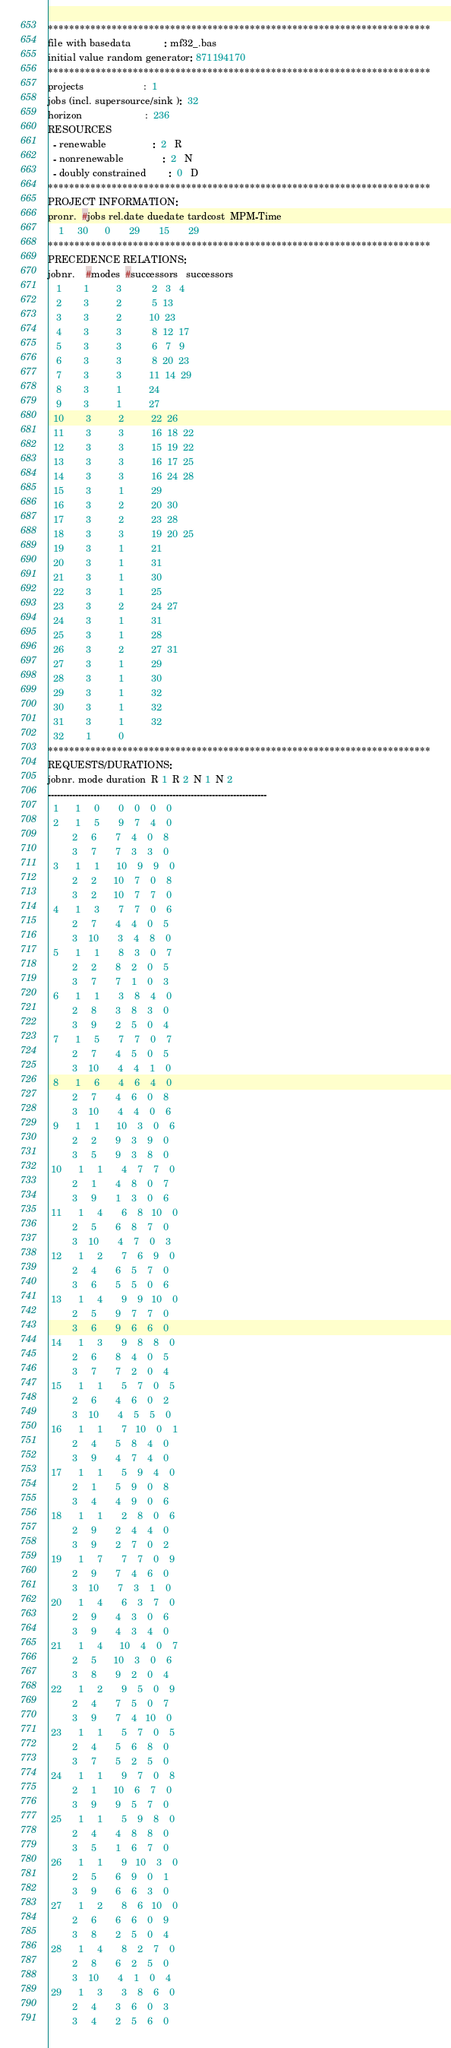Convert code to text. <code><loc_0><loc_0><loc_500><loc_500><_ObjectiveC_>************************************************************************
file with basedata            : mf32_.bas
initial value random generator: 871194170
************************************************************************
projects                      :  1
jobs (incl. supersource/sink ):  32
horizon                       :  236
RESOURCES
  - renewable                 :  2   R
  - nonrenewable              :  2   N
  - doubly constrained        :  0   D
************************************************************************
PROJECT INFORMATION:
pronr.  #jobs rel.date duedate tardcost  MPM-Time
    1     30      0       29       15       29
************************************************************************
PRECEDENCE RELATIONS:
jobnr.    #modes  #successors   successors
   1        1          3           2   3   4
   2        3          2           5  13
   3        3          2          10  23
   4        3          3           8  12  17
   5        3          3           6   7   9
   6        3          3           8  20  23
   7        3          3          11  14  29
   8        3          1          24
   9        3          1          27
  10        3          2          22  26
  11        3          3          16  18  22
  12        3          3          15  19  22
  13        3          3          16  17  25
  14        3          3          16  24  28
  15        3          1          29
  16        3          2          20  30
  17        3          2          23  28
  18        3          3          19  20  25
  19        3          1          21
  20        3          1          31
  21        3          1          30
  22        3          1          25
  23        3          2          24  27
  24        3          1          31
  25        3          1          28
  26        3          2          27  31
  27        3          1          29
  28        3          1          30
  29        3          1          32
  30        3          1          32
  31        3          1          32
  32        1          0        
************************************************************************
REQUESTS/DURATIONS:
jobnr. mode duration  R 1  R 2  N 1  N 2
------------------------------------------------------------------------
  1      1     0       0    0    0    0
  2      1     5       9    7    4    0
         2     6       7    4    0    8
         3     7       7    3    3    0
  3      1     1      10    9    9    0
         2     2      10    7    0    8
         3     2      10    7    7    0
  4      1     3       7    7    0    6
         2     7       4    4    0    5
         3    10       3    4    8    0
  5      1     1       8    3    0    7
         2     2       8    2    0    5
         3     7       7    1    0    3
  6      1     1       3    8    4    0
         2     8       3    8    3    0
         3     9       2    5    0    4
  7      1     5       7    7    0    7
         2     7       4    5    0    5
         3    10       4    4    1    0
  8      1     6       4    6    4    0
         2     7       4    6    0    8
         3    10       4    4    0    6
  9      1     1      10    3    0    6
         2     2       9    3    9    0
         3     5       9    3    8    0
 10      1     1       4    7    7    0
         2     1       4    8    0    7
         3     9       1    3    0    6
 11      1     4       6    8   10    0
         2     5       6    8    7    0
         3    10       4    7    0    3
 12      1     2       7    6    9    0
         2     4       6    5    7    0
         3     6       5    5    0    6
 13      1     4       9    9   10    0
         2     5       9    7    7    0
         3     6       9    6    6    0
 14      1     3       9    8    8    0
         2     6       8    4    0    5
         3     7       7    2    0    4
 15      1     1       5    7    0    5
         2     6       4    6    0    2
         3    10       4    5    5    0
 16      1     1       7   10    0    1
         2     4       5    8    4    0
         3     9       4    7    4    0
 17      1     1       5    9    4    0
         2     1       5    9    0    8
         3     4       4    9    0    6
 18      1     1       2    8    0    6
         2     9       2    4    4    0
         3     9       2    7    0    2
 19      1     7       7    7    0    9
         2     9       7    4    6    0
         3    10       7    3    1    0
 20      1     4       6    3    7    0
         2     9       4    3    0    6
         3     9       4    3    4    0
 21      1     4      10    4    0    7
         2     5      10    3    0    6
         3     8       9    2    0    4
 22      1     2       9    5    0    9
         2     4       7    5    0    7
         3     9       7    4   10    0
 23      1     1       5    7    0    5
         2     4       5    6    8    0
         3     7       5    2    5    0
 24      1     1       9    7    0    8
         2     1      10    6    7    0
         3     9       9    5    7    0
 25      1     1       5    9    8    0
         2     4       4    8    8    0
         3     5       1    6    7    0
 26      1     1       9   10    3    0
         2     5       6    9    0    1
         3     9       6    6    3    0
 27      1     2       8    6   10    0
         2     6       6    6    0    9
         3     8       2    5    0    4
 28      1     4       8    2    7    0
         2     8       6    2    5    0
         3    10       4    1    0    4
 29      1     3       3    8    6    0
         2     4       3    6    0    3
         3     4       2    5    6    0</code> 